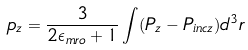Convert formula to latex. <formula><loc_0><loc_0><loc_500><loc_500>p _ { z } = \frac { 3 } { 2 \epsilon _ { m r o } + 1 } \int ( P _ { z } - P _ { i n c z } ) d ^ { 3 } r</formula> 